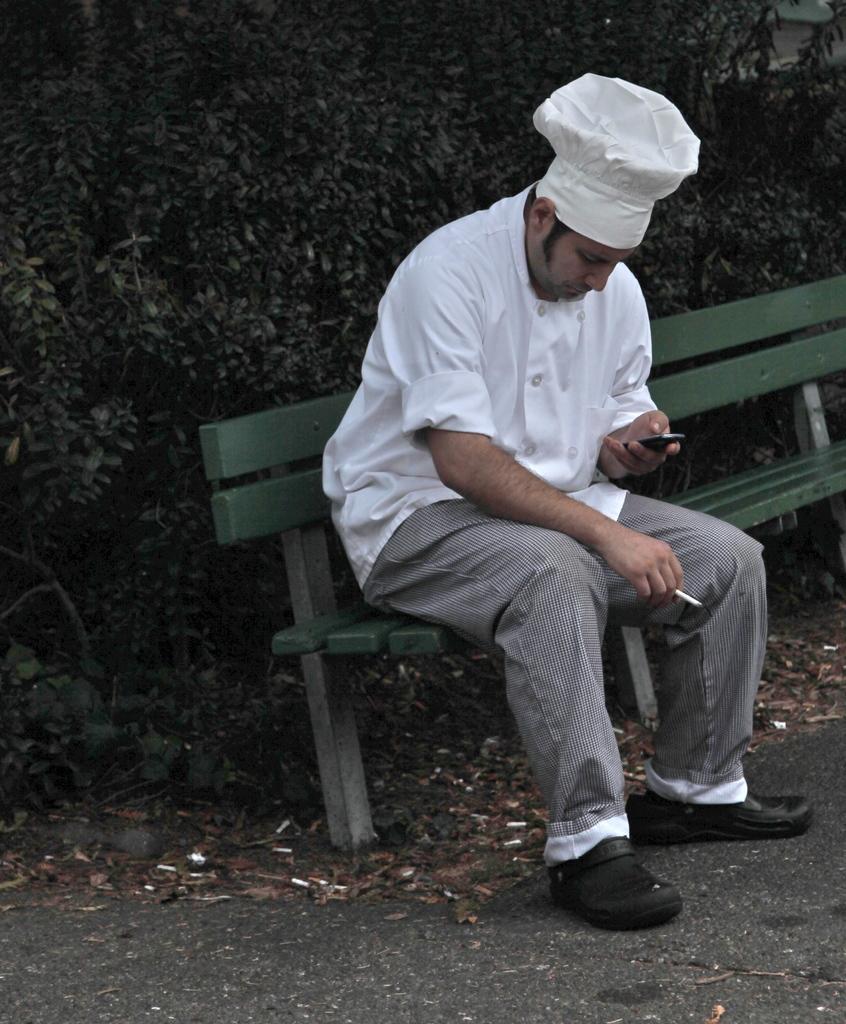In one or two sentences, can you explain what this image depicts? The image is taken on the road. In the center of the image there is a man sitting on a bench. He is holding a mobile in his hand. In the background there is a tree. 